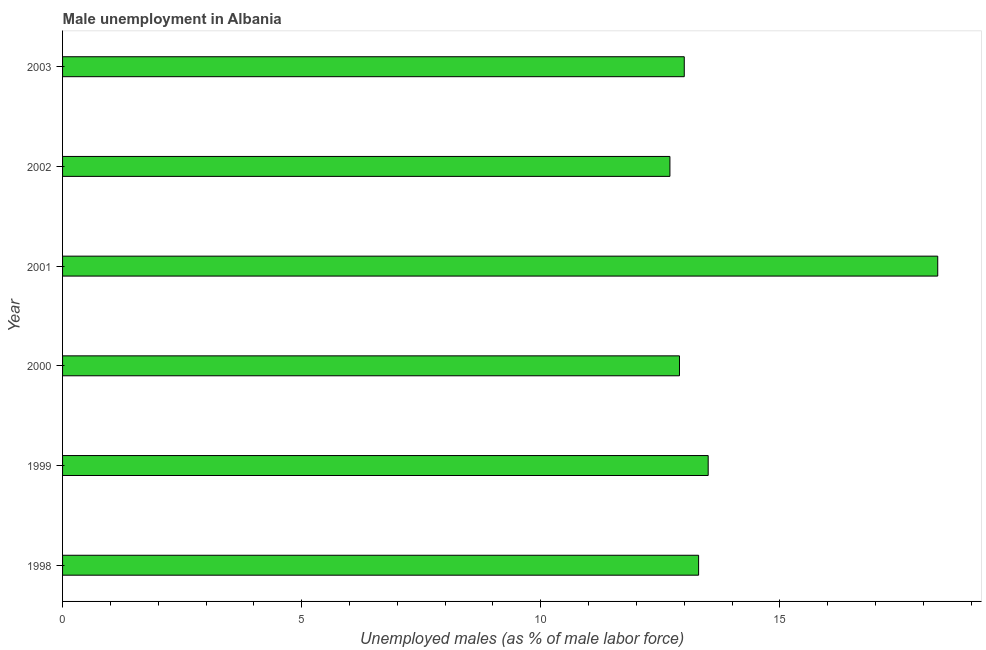Does the graph contain any zero values?
Offer a terse response. No. Does the graph contain grids?
Keep it short and to the point. No. What is the title of the graph?
Provide a succinct answer. Male unemployment in Albania. What is the label or title of the X-axis?
Provide a short and direct response. Unemployed males (as % of male labor force). What is the label or title of the Y-axis?
Your answer should be very brief. Year. What is the unemployed males population in 1998?
Ensure brevity in your answer.  13.3. Across all years, what is the maximum unemployed males population?
Your answer should be compact. 18.3. Across all years, what is the minimum unemployed males population?
Give a very brief answer. 12.7. What is the sum of the unemployed males population?
Ensure brevity in your answer.  83.7. What is the difference between the unemployed males population in 1998 and 2000?
Keep it short and to the point. 0.4. What is the average unemployed males population per year?
Make the answer very short. 13.95. What is the median unemployed males population?
Your response must be concise. 13.15. In how many years, is the unemployed males population greater than 10 %?
Make the answer very short. 6. Do a majority of the years between 1998 and 2003 (inclusive) have unemployed males population greater than 12 %?
Provide a short and direct response. Yes. What is the ratio of the unemployed males population in 1999 to that in 2003?
Offer a very short reply. 1.04. Is the unemployed males population in 1998 less than that in 2001?
Give a very brief answer. Yes. Is the difference between the unemployed males population in 2000 and 2001 greater than the difference between any two years?
Provide a short and direct response. No. What is the difference between the highest and the second highest unemployed males population?
Keep it short and to the point. 4.8. What is the difference between the highest and the lowest unemployed males population?
Your answer should be compact. 5.6. Are all the bars in the graph horizontal?
Offer a terse response. Yes. How many years are there in the graph?
Ensure brevity in your answer.  6. What is the difference between two consecutive major ticks on the X-axis?
Your answer should be compact. 5. Are the values on the major ticks of X-axis written in scientific E-notation?
Make the answer very short. No. What is the Unemployed males (as % of male labor force) of 1998?
Offer a very short reply. 13.3. What is the Unemployed males (as % of male labor force) in 2000?
Your answer should be compact. 12.9. What is the Unemployed males (as % of male labor force) of 2001?
Offer a terse response. 18.3. What is the Unemployed males (as % of male labor force) of 2002?
Keep it short and to the point. 12.7. What is the difference between the Unemployed males (as % of male labor force) in 1998 and 1999?
Give a very brief answer. -0.2. What is the difference between the Unemployed males (as % of male labor force) in 1998 and 2001?
Your answer should be very brief. -5. What is the difference between the Unemployed males (as % of male labor force) in 1998 and 2002?
Make the answer very short. 0.6. What is the difference between the Unemployed males (as % of male labor force) in 1999 and 2003?
Offer a very short reply. 0.5. What is the difference between the Unemployed males (as % of male labor force) in 2000 and 2001?
Make the answer very short. -5.4. What is the difference between the Unemployed males (as % of male labor force) in 2000 and 2002?
Your response must be concise. 0.2. What is the difference between the Unemployed males (as % of male labor force) in 2000 and 2003?
Your answer should be compact. -0.1. What is the difference between the Unemployed males (as % of male labor force) in 2001 and 2003?
Provide a short and direct response. 5.3. What is the difference between the Unemployed males (as % of male labor force) in 2002 and 2003?
Keep it short and to the point. -0.3. What is the ratio of the Unemployed males (as % of male labor force) in 1998 to that in 1999?
Give a very brief answer. 0.98. What is the ratio of the Unemployed males (as % of male labor force) in 1998 to that in 2000?
Your response must be concise. 1.03. What is the ratio of the Unemployed males (as % of male labor force) in 1998 to that in 2001?
Provide a succinct answer. 0.73. What is the ratio of the Unemployed males (as % of male labor force) in 1998 to that in 2002?
Your answer should be very brief. 1.05. What is the ratio of the Unemployed males (as % of male labor force) in 1998 to that in 2003?
Provide a succinct answer. 1.02. What is the ratio of the Unemployed males (as % of male labor force) in 1999 to that in 2000?
Provide a succinct answer. 1.05. What is the ratio of the Unemployed males (as % of male labor force) in 1999 to that in 2001?
Offer a terse response. 0.74. What is the ratio of the Unemployed males (as % of male labor force) in 1999 to that in 2002?
Provide a succinct answer. 1.06. What is the ratio of the Unemployed males (as % of male labor force) in 1999 to that in 2003?
Your answer should be compact. 1.04. What is the ratio of the Unemployed males (as % of male labor force) in 2000 to that in 2001?
Make the answer very short. 0.7. What is the ratio of the Unemployed males (as % of male labor force) in 2000 to that in 2002?
Keep it short and to the point. 1.02. What is the ratio of the Unemployed males (as % of male labor force) in 2001 to that in 2002?
Ensure brevity in your answer.  1.44. What is the ratio of the Unemployed males (as % of male labor force) in 2001 to that in 2003?
Make the answer very short. 1.41. 